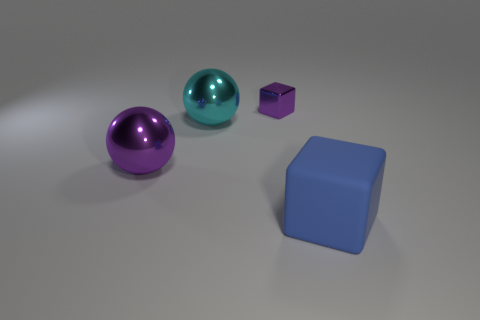Add 3 tiny rubber blocks. How many objects exist? 7 Add 1 large metallic objects. How many large metallic objects are left? 3 Add 4 large yellow metal things. How many large yellow metal things exist? 4 Subtract 0 blue cylinders. How many objects are left? 4 Subtract all large balls. Subtract all purple metallic things. How many objects are left? 0 